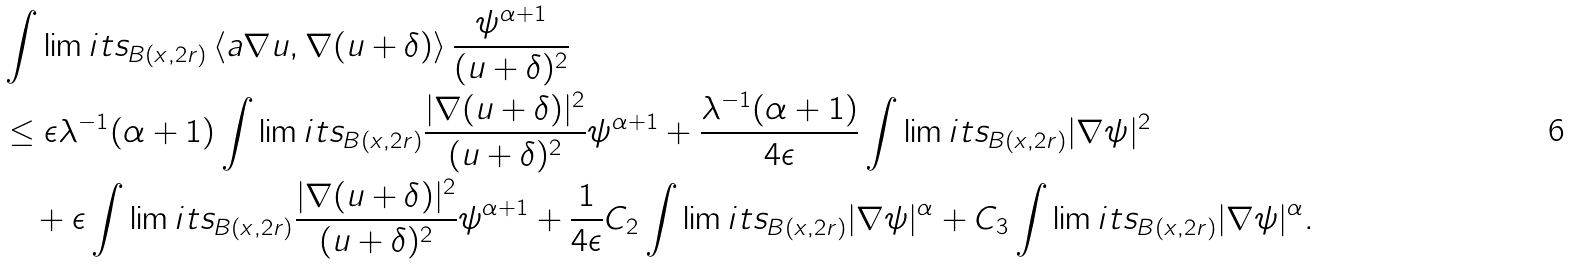<formula> <loc_0><loc_0><loc_500><loc_500>& \int \lim i t s _ { B ( x , 2 r ) } \left \langle a \nabla u , \nabla ( u + \delta ) \right \rangle \frac { \psi ^ { \alpha + 1 } } { ( u + \delta ) ^ { 2 } } \\ & \leq \epsilon \lambda ^ { - 1 } ( \alpha + 1 ) \int \lim i t s _ { B ( x , 2 r ) } \frac { | \nabla ( u + \delta ) | ^ { 2 } } { ( u + \delta ) ^ { 2 } } \psi ^ { \alpha + 1 } + \frac { \lambda ^ { - 1 } ( \alpha + 1 ) } { 4 \epsilon } \int \lim i t s _ { B ( x , 2 r ) } | \nabla \psi | ^ { 2 } \\ & \quad + \epsilon \int \lim i t s _ { B ( x , 2 r ) } \frac { | \nabla ( u + \delta ) | ^ { 2 } } { ( u + \delta ) ^ { 2 } } \psi ^ { \alpha + 1 } + \frac { 1 } { 4 \epsilon } C _ { 2 } \int \lim i t s _ { B ( x , 2 r ) } | \nabla \psi | ^ { \alpha } + C _ { 3 } \int \lim i t s _ { B ( x , 2 r ) } | \nabla \psi | ^ { \alpha } .</formula> 